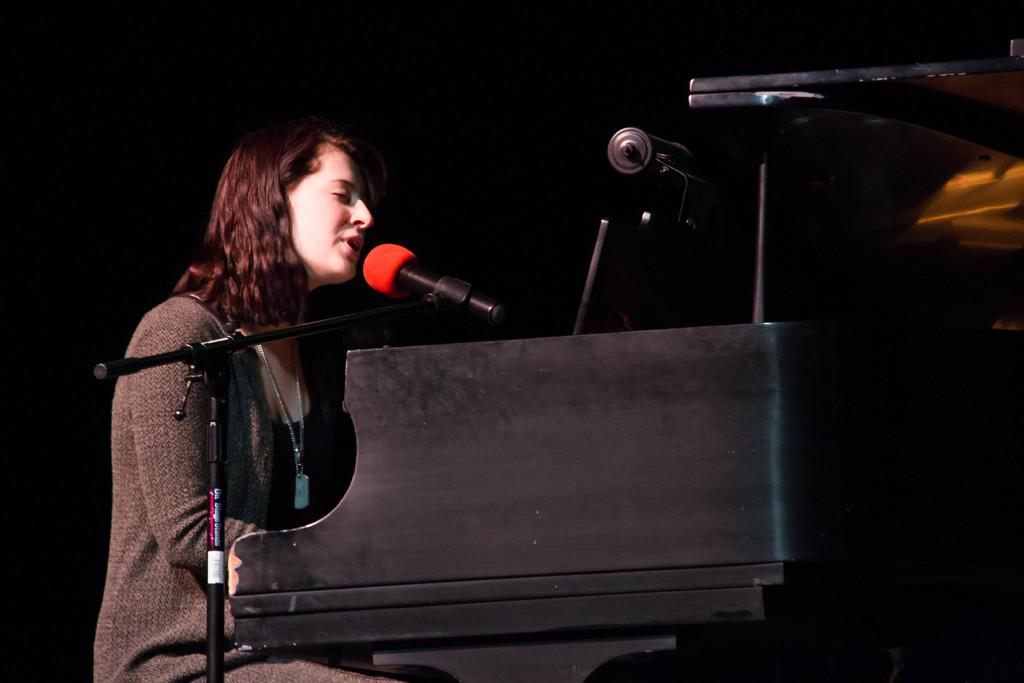What is the person in the image doing? The person is sitting on a seating stool in the image. What object is associated with the person's activity? A musical instrument is present in the image. What device is placed in front of the person? A microphone (mic) is placed in front of the person. How many kittens are playing with the eggs in the image? There are no kittens or eggs present in the image. What angle is the person sitting at in the image? The angle at which the person is sitting cannot be determined from the image alone, as it only provides a two-dimensional representation. 